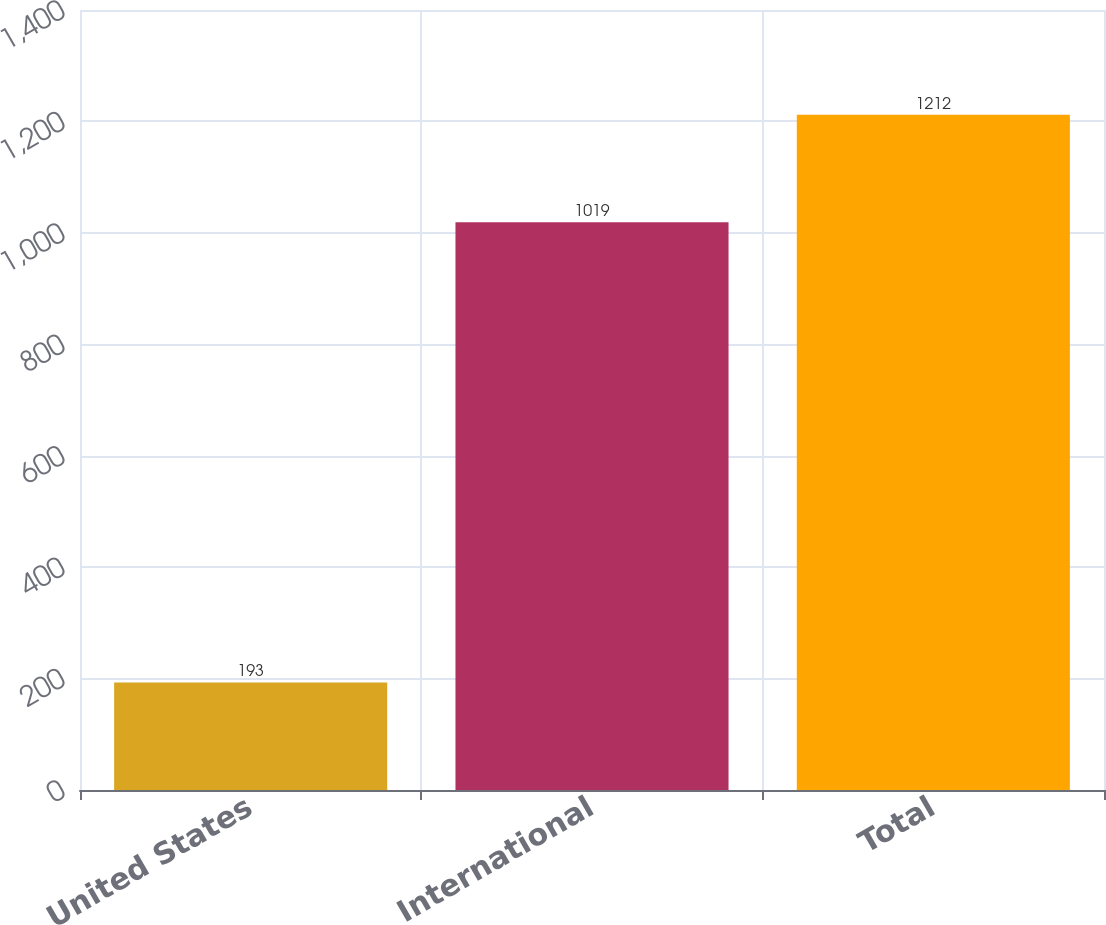Convert chart. <chart><loc_0><loc_0><loc_500><loc_500><bar_chart><fcel>United States<fcel>International<fcel>Total<nl><fcel>193<fcel>1019<fcel>1212<nl></chart> 